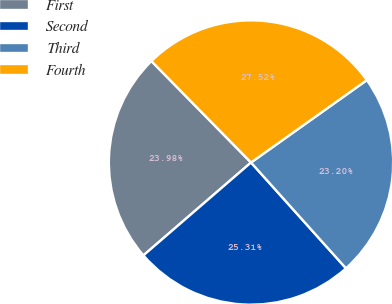Convert chart. <chart><loc_0><loc_0><loc_500><loc_500><pie_chart><fcel>First<fcel>Second<fcel>Third<fcel>Fourth<nl><fcel>23.98%<fcel>25.31%<fcel>23.2%<fcel>27.52%<nl></chart> 